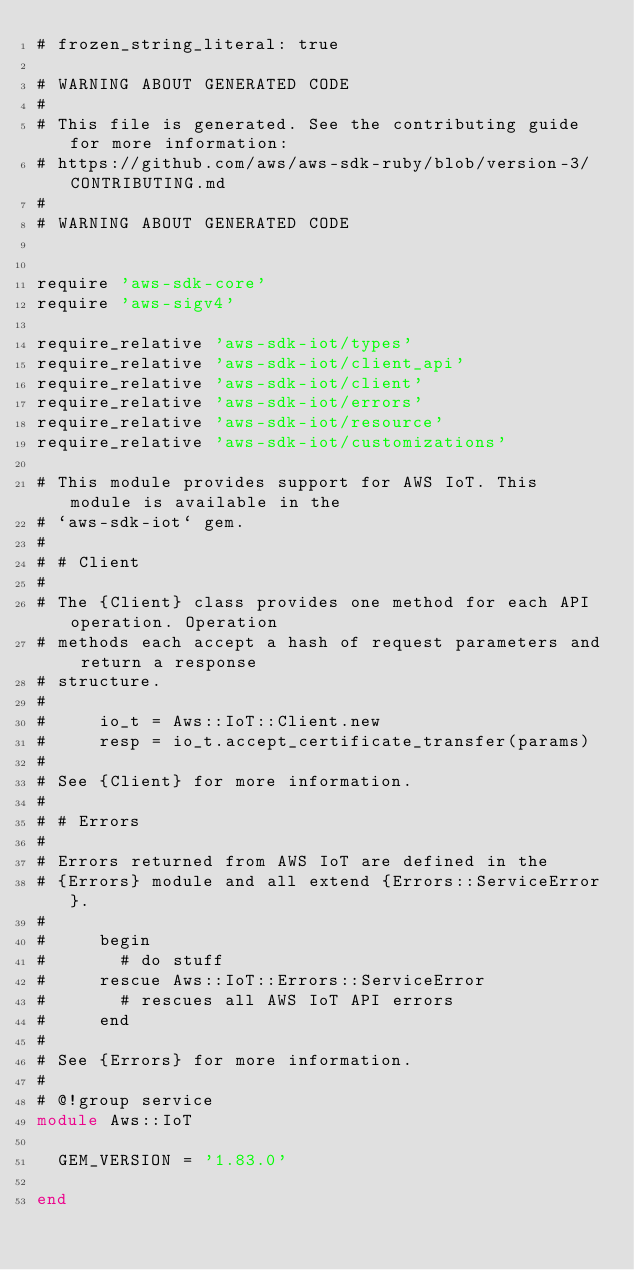Convert code to text. <code><loc_0><loc_0><loc_500><loc_500><_Ruby_># frozen_string_literal: true

# WARNING ABOUT GENERATED CODE
#
# This file is generated. See the contributing guide for more information:
# https://github.com/aws/aws-sdk-ruby/blob/version-3/CONTRIBUTING.md
#
# WARNING ABOUT GENERATED CODE


require 'aws-sdk-core'
require 'aws-sigv4'

require_relative 'aws-sdk-iot/types'
require_relative 'aws-sdk-iot/client_api'
require_relative 'aws-sdk-iot/client'
require_relative 'aws-sdk-iot/errors'
require_relative 'aws-sdk-iot/resource'
require_relative 'aws-sdk-iot/customizations'

# This module provides support for AWS IoT. This module is available in the
# `aws-sdk-iot` gem.
#
# # Client
#
# The {Client} class provides one method for each API operation. Operation
# methods each accept a hash of request parameters and return a response
# structure.
#
#     io_t = Aws::IoT::Client.new
#     resp = io_t.accept_certificate_transfer(params)
#
# See {Client} for more information.
#
# # Errors
#
# Errors returned from AWS IoT are defined in the
# {Errors} module and all extend {Errors::ServiceError}.
#
#     begin
#       # do stuff
#     rescue Aws::IoT::Errors::ServiceError
#       # rescues all AWS IoT API errors
#     end
#
# See {Errors} for more information.
#
# @!group service
module Aws::IoT

  GEM_VERSION = '1.83.0'

end
</code> 